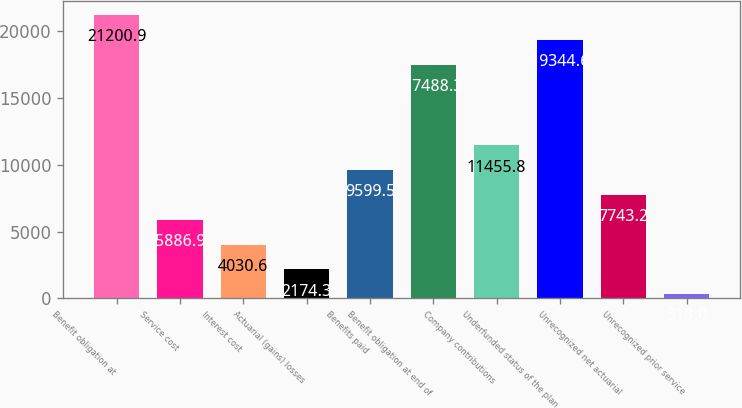Convert chart to OTSL. <chart><loc_0><loc_0><loc_500><loc_500><bar_chart><fcel>Benefit obligation at<fcel>Service cost<fcel>Interest cost<fcel>Actuarial (gains) losses<fcel>Benefits paid<fcel>Benefit obligation at end of<fcel>Company contributions<fcel>Underfunded status of the plan<fcel>Unrecognized net actuarial<fcel>Unrecognized prior service<nl><fcel>21200.9<fcel>5886.9<fcel>4030.6<fcel>2174.3<fcel>9599.5<fcel>17488.3<fcel>11455.8<fcel>19344.6<fcel>7743.2<fcel>318<nl></chart> 